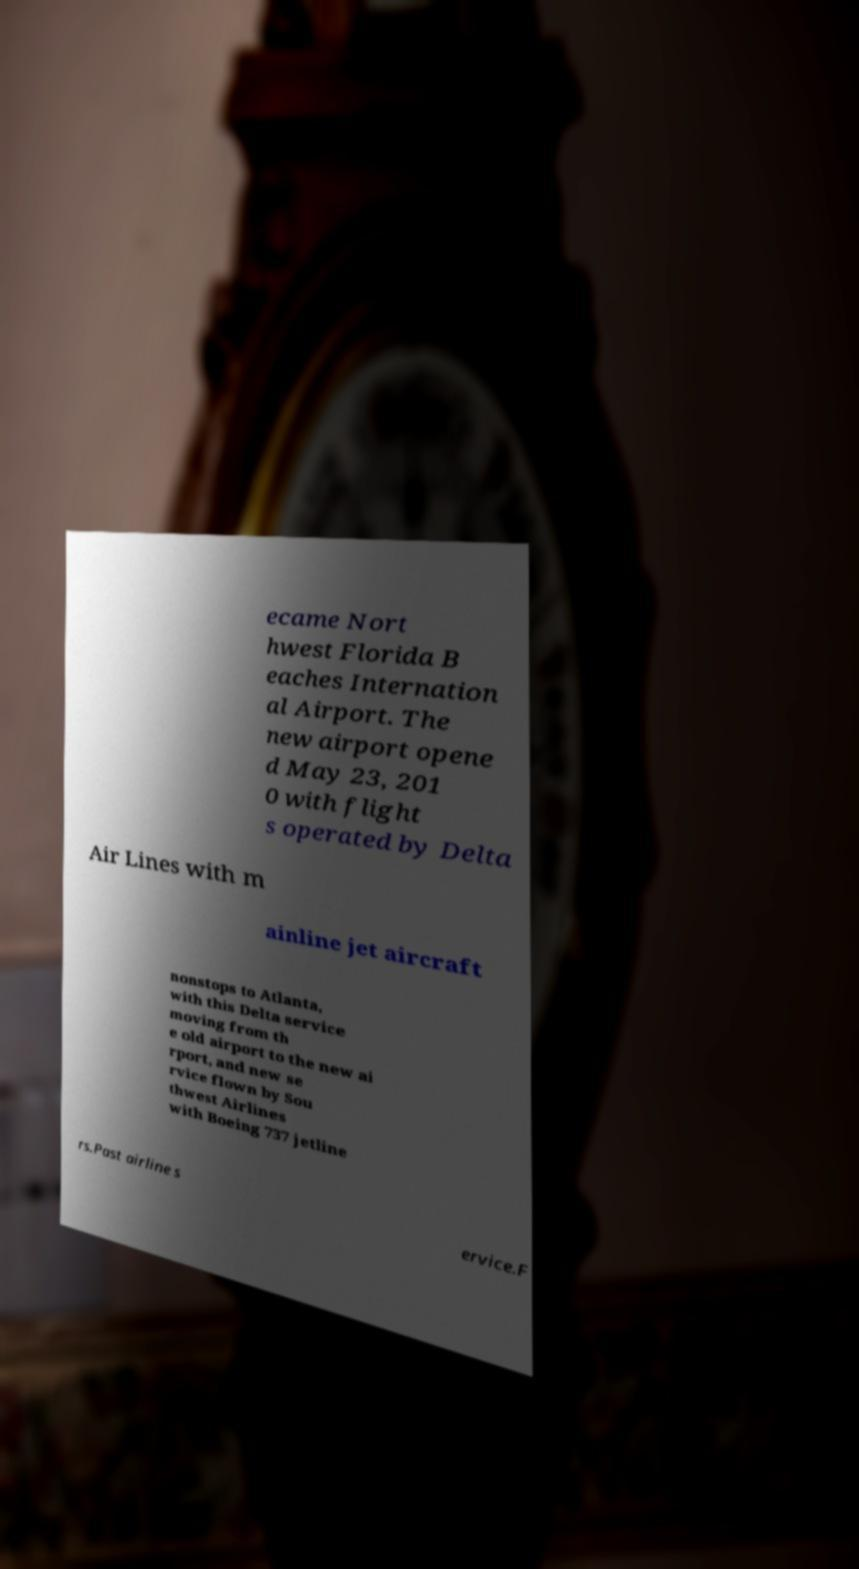What messages or text are displayed in this image? I need them in a readable, typed format. ecame Nort hwest Florida B eaches Internation al Airport. The new airport opene d May 23, 201 0 with flight s operated by Delta Air Lines with m ainline jet aircraft nonstops to Atlanta, with this Delta service moving from th e old airport to the new ai rport, and new se rvice flown by Sou thwest Airlines with Boeing 737 jetline rs.Past airline s ervice.F 